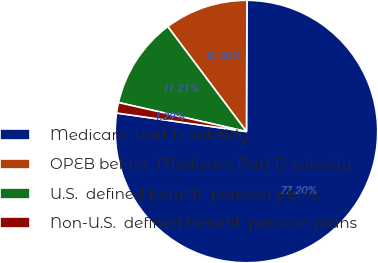<chart> <loc_0><loc_0><loc_500><loc_500><pie_chart><fcel>Medicare  Part D subsidy<fcel>OPEB before  Medicare Part D subsidy<fcel>U.S.  defined benefit  pension plans<fcel>Non-U.S.  defined benefit  pension plans<nl><fcel>77.19%<fcel>10.3%<fcel>11.21%<fcel>1.29%<nl></chart> 